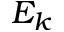<formula> <loc_0><loc_0><loc_500><loc_500>E _ { k }</formula> 